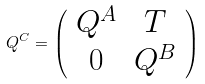<formula> <loc_0><loc_0><loc_500><loc_500>Q ^ { C } = \left ( \begin{array} { c c } Q ^ { A } & T \\ 0 & Q ^ { B } \end{array} \right )</formula> 